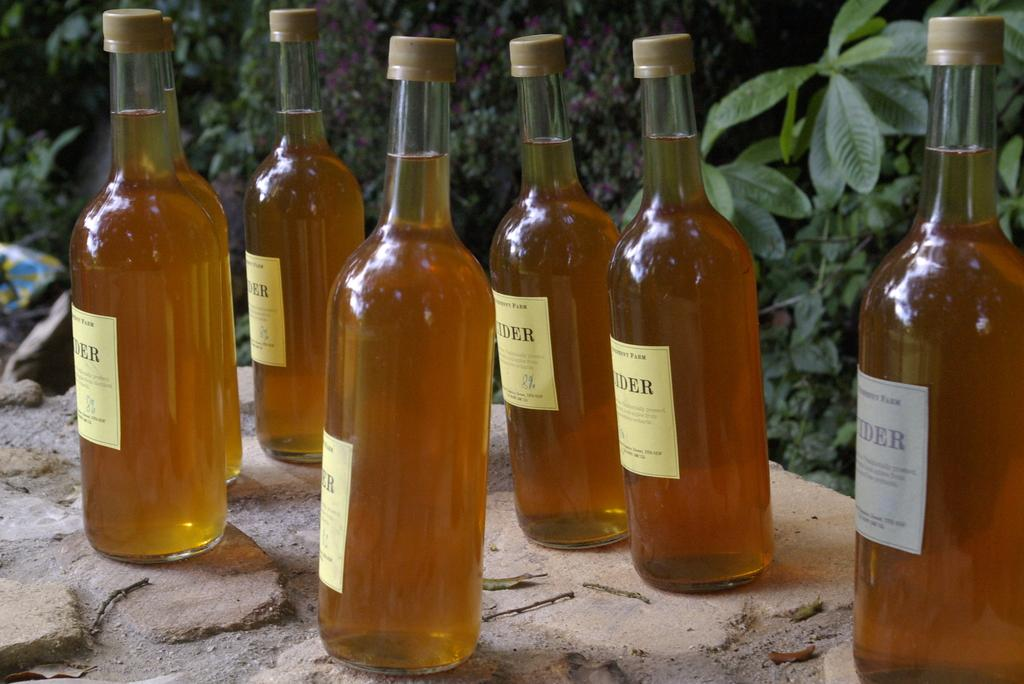What can be found in the bottles in the image? There are liquids in the bottles in the image. Are there any additional features on the bottles? Yes, the bottles have stickers on them. What else is present in the image besides the bottles? There are plants in the image. How many lizards can be seen climbing on the plants in the image? There are no lizards present in the image; it only features bottles with liquids and stickers, as well as plants. 